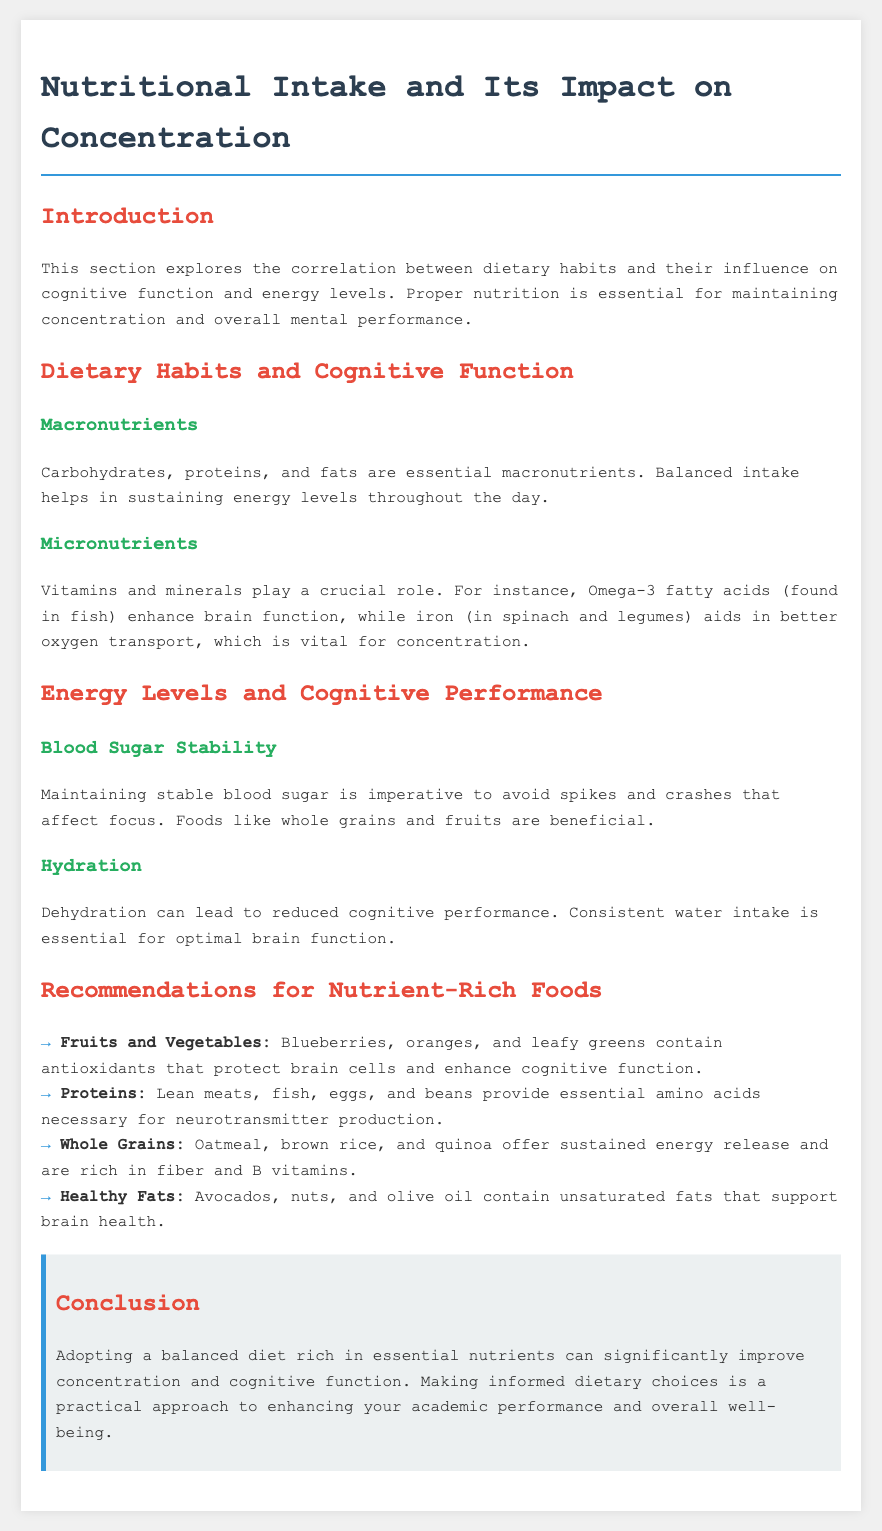what is the title of the document? The title of the document is stated in the header section, which outlines the main focus of the content.
Answer: Nutritional Intake and Its Impact on Concentration what role do macronutrients play? The document mentions that macronutrients are essential for maintaining energy levels throughout the day.
Answer: Sustaining energy levels which micronutrient is found in fish? The document specifies that Omega-3 fatty acids are a micronutrient found in fish that enhance brain function.
Answer: Omega-3 fatty acids what type of foods help maintain stable blood sugar? The document lists certain foods that are beneficial for blood sugar stability.
Answer: Whole grains and fruits name one fruit recommended for brain health. The document recommends a variety of fruits for cognitive function, specifying particular examples.
Answer: Blueberries what is the importance of hydration according to the document? The document explains that hydration is essential for optimal brain function and cognitive performance.
Answer: Reduced cognitive performance list one nutrient-rich food high in healthy fats. The document provides recommendations for nutrient-rich foods, mentioning sources of healthy fats.
Answer: Avocados how does a balanced diet affect academic performance? The document concludes by stating the overall impact of dietary choices on a specific aspect of life for students.
Answer: Improve concentration and cognitive function 